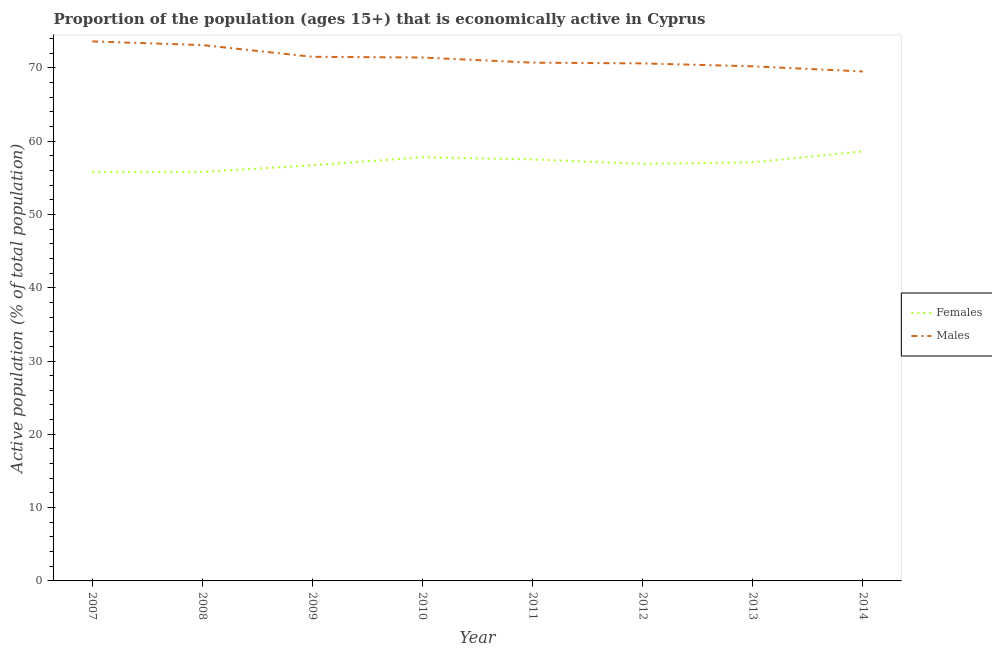How many different coloured lines are there?
Offer a very short reply. 2. Does the line corresponding to percentage of economically active male population intersect with the line corresponding to percentage of economically active female population?
Your response must be concise. No. What is the percentage of economically active female population in 2013?
Your answer should be compact. 57.1. Across all years, what is the maximum percentage of economically active male population?
Provide a succinct answer. 73.6. Across all years, what is the minimum percentage of economically active female population?
Ensure brevity in your answer.  55.8. In which year was the percentage of economically active male population minimum?
Provide a short and direct response. 2014. What is the total percentage of economically active male population in the graph?
Ensure brevity in your answer.  570.6. What is the difference between the percentage of economically active female population in 2009 and that in 2012?
Your response must be concise. -0.2. What is the difference between the percentage of economically active female population in 2013 and the percentage of economically active male population in 2014?
Offer a very short reply. -12.4. What is the average percentage of economically active female population per year?
Provide a succinct answer. 57.02. In the year 2009, what is the difference between the percentage of economically active female population and percentage of economically active male population?
Provide a short and direct response. -14.8. In how many years, is the percentage of economically active female population greater than 26 %?
Keep it short and to the point. 8. What is the ratio of the percentage of economically active female population in 2010 to that in 2014?
Keep it short and to the point. 0.99. Is the percentage of economically active male population in 2008 less than that in 2011?
Give a very brief answer. No. Is the difference between the percentage of economically active male population in 2011 and 2014 greater than the difference between the percentage of economically active female population in 2011 and 2014?
Give a very brief answer. Yes. What is the difference between the highest and the second highest percentage of economically active female population?
Your response must be concise. 0.8. What is the difference between the highest and the lowest percentage of economically active female population?
Your answer should be very brief. 2.8. In how many years, is the percentage of economically active male population greater than the average percentage of economically active male population taken over all years?
Ensure brevity in your answer.  4. Is the percentage of economically active male population strictly greater than the percentage of economically active female population over the years?
Make the answer very short. Yes. Is the percentage of economically active male population strictly less than the percentage of economically active female population over the years?
Give a very brief answer. No. Are the values on the major ticks of Y-axis written in scientific E-notation?
Offer a terse response. No. Where does the legend appear in the graph?
Ensure brevity in your answer.  Center right. What is the title of the graph?
Ensure brevity in your answer.  Proportion of the population (ages 15+) that is economically active in Cyprus. Does "Crop" appear as one of the legend labels in the graph?
Give a very brief answer. No. What is the label or title of the Y-axis?
Offer a terse response. Active population (% of total population). What is the Active population (% of total population) of Females in 2007?
Your response must be concise. 55.8. What is the Active population (% of total population) of Males in 2007?
Ensure brevity in your answer.  73.6. What is the Active population (% of total population) of Females in 2008?
Provide a short and direct response. 55.8. What is the Active population (% of total population) of Males in 2008?
Your response must be concise. 73.1. What is the Active population (% of total population) in Females in 2009?
Keep it short and to the point. 56.7. What is the Active population (% of total population) of Males in 2009?
Keep it short and to the point. 71.5. What is the Active population (% of total population) in Females in 2010?
Provide a succinct answer. 57.8. What is the Active population (% of total population) of Males in 2010?
Provide a succinct answer. 71.4. What is the Active population (% of total population) of Females in 2011?
Provide a succinct answer. 57.5. What is the Active population (% of total population) of Males in 2011?
Your response must be concise. 70.7. What is the Active population (% of total population) of Females in 2012?
Make the answer very short. 56.9. What is the Active population (% of total population) in Males in 2012?
Offer a terse response. 70.6. What is the Active population (% of total population) in Females in 2013?
Ensure brevity in your answer.  57.1. What is the Active population (% of total population) of Males in 2013?
Keep it short and to the point. 70.2. What is the Active population (% of total population) in Females in 2014?
Your response must be concise. 58.6. What is the Active population (% of total population) in Males in 2014?
Your answer should be very brief. 69.5. Across all years, what is the maximum Active population (% of total population) of Females?
Your answer should be very brief. 58.6. Across all years, what is the maximum Active population (% of total population) in Males?
Provide a short and direct response. 73.6. Across all years, what is the minimum Active population (% of total population) in Females?
Offer a very short reply. 55.8. Across all years, what is the minimum Active population (% of total population) of Males?
Provide a succinct answer. 69.5. What is the total Active population (% of total population) of Females in the graph?
Offer a very short reply. 456.2. What is the total Active population (% of total population) of Males in the graph?
Give a very brief answer. 570.6. What is the difference between the Active population (% of total population) in Females in 2007 and that in 2008?
Provide a succinct answer. 0. What is the difference between the Active population (% of total population) in Males in 2007 and that in 2010?
Your answer should be compact. 2.2. What is the difference between the Active population (% of total population) of Females in 2007 and that in 2011?
Give a very brief answer. -1.7. What is the difference between the Active population (% of total population) of Males in 2007 and that in 2013?
Give a very brief answer. 3.4. What is the difference between the Active population (% of total population) in Females in 2008 and that in 2009?
Your answer should be compact. -0.9. What is the difference between the Active population (% of total population) in Males in 2008 and that in 2009?
Your answer should be very brief. 1.6. What is the difference between the Active population (% of total population) in Females in 2008 and that in 2010?
Make the answer very short. -2. What is the difference between the Active population (% of total population) in Males in 2008 and that in 2010?
Make the answer very short. 1.7. What is the difference between the Active population (% of total population) in Females in 2008 and that in 2011?
Give a very brief answer. -1.7. What is the difference between the Active population (% of total population) of Males in 2008 and that in 2011?
Offer a very short reply. 2.4. What is the difference between the Active population (% of total population) in Males in 2008 and that in 2012?
Provide a succinct answer. 2.5. What is the difference between the Active population (% of total population) of Females in 2008 and that in 2013?
Keep it short and to the point. -1.3. What is the difference between the Active population (% of total population) in Females in 2009 and that in 2011?
Make the answer very short. -0.8. What is the difference between the Active population (% of total population) of Females in 2009 and that in 2012?
Provide a short and direct response. -0.2. What is the difference between the Active population (% of total population) in Females in 2009 and that in 2013?
Provide a succinct answer. -0.4. What is the difference between the Active population (% of total population) in Females in 2010 and that in 2011?
Ensure brevity in your answer.  0.3. What is the difference between the Active population (% of total population) of Males in 2010 and that in 2011?
Ensure brevity in your answer.  0.7. What is the difference between the Active population (% of total population) in Females in 2010 and that in 2012?
Make the answer very short. 0.9. What is the difference between the Active population (% of total population) in Females in 2010 and that in 2014?
Your answer should be very brief. -0.8. What is the difference between the Active population (% of total population) of Males in 2010 and that in 2014?
Give a very brief answer. 1.9. What is the difference between the Active population (% of total population) in Females in 2011 and that in 2013?
Offer a very short reply. 0.4. What is the difference between the Active population (% of total population) in Females in 2011 and that in 2014?
Keep it short and to the point. -1.1. What is the difference between the Active population (% of total population) of Females in 2012 and that in 2014?
Provide a succinct answer. -1.7. What is the difference between the Active population (% of total population) in Males in 2012 and that in 2014?
Provide a short and direct response. 1.1. What is the difference between the Active population (% of total population) in Males in 2013 and that in 2014?
Your answer should be very brief. 0.7. What is the difference between the Active population (% of total population) in Females in 2007 and the Active population (% of total population) in Males in 2008?
Your answer should be compact. -17.3. What is the difference between the Active population (% of total population) of Females in 2007 and the Active population (% of total population) of Males in 2009?
Keep it short and to the point. -15.7. What is the difference between the Active population (% of total population) of Females in 2007 and the Active population (% of total population) of Males in 2010?
Give a very brief answer. -15.6. What is the difference between the Active population (% of total population) of Females in 2007 and the Active population (% of total population) of Males in 2011?
Your answer should be compact. -14.9. What is the difference between the Active population (% of total population) in Females in 2007 and the Active population (% of total population) in Males in 2012?
Make the answer very short. -14.8. What is the difference between the Active population (% of total population) of Females in 2007 and the Active population (% of total population) of Males in 2013?
Offer a very short reply. -14.4. What is the difference between the Active population (% of total population) of Females in 2007 and the Active population (% of total population) of Males in 2014?
Your answer should be very brief. -13.7. What is the difference between the Active population (% of total population) of Females in 2008 and the Active population (% of total population) of Males in 2009?
Ensure brevity in your answer.  -15.7. What is the difference between the Active population (% of total population) in Females in 2008 and the Active population (% of total population) in Males in 2010?
Offer a terse response. -15.6. What is the difference between the Active population (% of total population) of Females in 2008 and the Active population (% of total population) of Males in 2011?
Make the answer very short. -14.9. What is the difference between the Active population (% of total population) of Females in 2008 and the Active population (% of total population) of Males in 2012?
Give a very brief answer. -14.8. What is the difference between the Active population (% of total population) of Females in 2008 and the Active population (% of total population) of Males in 2013?
Offer a very short reply. -14.4. What is the difference between the Active population (% of total population) in Females in 2008 and the Active population (% of total population) in Males in 2014?
Offer a very short reply. -13.7. What is the difference between the Active population (% of total population) in Females in 2009 and the Active population (% of total population) in Males in 2010?
Provide a short and direct response. -14.7. What is the difference between the Active population (% of total population) in Females in 2009 and the Active population (% of total population) in Males in 2012?
Make the answer very short. -13.9. What is the difference between the Active population (% of total population) in Females in 2009 and the Active population (% of total population) in Males in 2013?
Your answer should be compact. -13.5. What is the difference between the Active population (% of total population) in Females in 2010 and the Active population (% of total population) in Males in 2011?
Ensure brevity in your answer.  -12.9. What is the difference between the Active population (% of total population) in Females in 2010 and the Active population (% of total population) in Males in 2014?
Your answer should be compact. -11.7. What is the difference between the Active population (% of total population) of Females in 2011 and the Active population (% of total population) of Males in 2012?
Offer a very short reply. -13.1. What is the difference between the Active population (% of total population) of Females in 2011 and the Active population (% of total population) of Males in 2013?
Offer a terse response. -12.7. What is the difference between the Active population (% of total population) of Females in 2011 and the Active population (% of total population) of Males in 2014?
Give a very brief answer. -12. What is the difference between the Active population (% of total population) in Females in 2012 and the Active population (% of total population) in Males in 2013?
Your response must be concise. -13.3. What is the difference between the Active population (% of total population) of Females in 2012 and the Active population (% of total population) of Males in 2014?
Provide a succinct answer. -12.6. What is the difference between the Active population (% of total population) in Females in 2013 and the Active population (% of total population) in Males in 2014?
Provide a succinct answer. -12.4. What is the average Active population (% of total population) in Females per year?
Your response must be concise. 57.02. What is the average Active population (% of total population) in Males per year?
Offer a very short reply. 71.33. In the year 2007, what is the difference between the Active population (% of total population) in Females and Active population (% of total population) in Males?
Keep it short and to the point. -17.8. In the year 2008, what is the difference between the Active population (% of total population) of Females and Active population (% of total population) of Males?
Make the answer very short. -17.3. In the year 2009, what is the difference between the Active population (% of total population) in Females and Active population (% of total population) in Males?
Ensure brevity in your answer.  -14.8. In the year 2011, what is the difference between the Active population (% of total population) in Females and Active population (% of total population) in Males?
Your answer should be very brief. -13.2. In the year 2012, what is the difference between the Active population (% of total population) in Females and Active population (% of total population) in Males?
Your response must be concise. -13.7. In the year 2013, what is the difference between the Active population (% of total population) of Females and Active population (% of total population) of Males?
Your answer should be very brief. -13.1. What is the ratio of the Active population (% of total population) of Females in 2007 to that in 2008?
Your answer should be very brief. 1. What is the ratio of the Active population (% of total population) of Males in 2007 to that in 2008?
Ensure brevity in your answer.  1.01. What is the ratio of the Active population (% of total population) of Females in 2007 to that in 2009?
Your response must be concise. 0.98. What is the ratio of the Active population (% of total population) of Males in 2007 to that in 2009?
Provide a succinct answer. 1.03. What is the ratio of the Active population (% of total population) in Females in 2007 to that in 2010?
Keep it short and to the point. 0.97. What is the ratio of the Active population (% of total population) in Males in 2007 to that in 2010?
Your answer should be compact. 1.03. What is the ratio of the Active population (% of total population) in Females in 2007 to that in 2011?
Offer a very short reply. 0.97. What is the ratio of the Active population (% of total population) of Males in 2007 to that in 2011?
Your answer should be very brief. 1.04. What is the ratio of the Active population (% of total population) of Females in 2007 to that in 2012?
Your answer should be compact. 0.98. What is the ratio of the Active population (% of total population) in Males in 2007 to that in 2012?
Make the answer very short. 1.04. What is the ratio of the Active population (% of total population) of Females in 2007 to that in 2013?
Offer a terse response. 0.98. What is the ratio of the Active population (% of total population) of Males in 2007 to that in 2013?
Your response must be concise. 1.05. What is the ratio of the Active population (% of total population) in Females in 2007 to that in 2014?
Offer a terse response. 0.95. What is the ratio of the Active population (% of total population) in Males in 2007 to that in 2014?
Ensure brevity in your answer.  1.06. What is the ratio of the Active population (% of total population) in Females in 2008 to that in 2009?
Provide a succinct answer. 0.98. What is the ratio of the Active population (% of total population) of Males in 2008 to that in 2009?
Your answer should be very brief. 1.02. What is the ratio of the Active population (% of total population) in Females in 2008 to that in 2010?
Make the answer very short. 0.97. What is the ratio of the Active population (% of total population) of Males in 2008 to that in 2010?
Provide a short and direct response. 1.02. What is the ratio of the Active population (% of total population) in Females in 2008 to that in 2011?
Ensure brevity in your answer.  0.97. What is the ratio of the Active population (% of total population) of Males in 2008 to that in 2011?
Keep it short and to the point. 1.03. What is the ratio of the Active population (% of total population) in Females in 2008 to that in 2012?
Keep it short and to the point. 0.98. What is the ratio of the Active population (% of total population) of Males in 2008 to that in 2012?
Your answer should be compact. 1.04. What is the ratio of the Active population (% of total population) of Females in 2008 to that in 2013?
Your answer should be compact. 0.98. What is the ratio of the Active population (% of total population) in Males in 2008 to that in 2013?
Your answer should be very brief. 1.04. What is the ratio of the Active population (% of total population) of Females in 2008 to that in 2014?
Give a very brief answer. 0.95. What is the ratio of the Active population (% of total population) in Males in 2008 to that in 2014?
Your response must be concise. 1.05. What is the ratio of the Active population (% of total population) in Males in 2009 to that in 2010?
Provide a succinct answer. 1. What is the ratio of the Active population (% of total population) of Females in 2009 to that in 2011?
Your response must be concise. 0.99. What is the ratio of the Active population (% of total population) of Males in 2009 to that in 2011?
Make the answer very short. 1.01. What is the ratio of the Active population (% of total population) in Males in 2009 to that in 2012?
Your response must be concise. 1.01. What is the ratio of the Active population (% of total population) of Males in 2009 to that in 2013?
Your answer should be compact. 1.02. What is the ratio of the Active population (% of total population) of Females in 2009 to that in 2014?
Your response must be concise. 0.97. What is the ratio of the Active population (% of total population) of Males in 2009 to that in 2014?
Make the answer very short. 1.03. What is the ratio of the Active population (% of total population) in Males in 2010 to that in 2011?
Keep it short and to the point. 1.01. What is the ratio of the Active population (% of total population) in Females in 2010 to that in 2012?
Provide a succinct answer. 1.02. What is the ratio of the Active population (% of total population) in Males in 2010 to that in 2012?
Ensure brevity in your answer.  1.01. What is the ratio of the Active population (% of total population) of Females in 2010 to that in 2013?
Your response must be concise. 1.01. What is the ratio of the Active population (% of total population) of Males in 2010 to that in 2013?
Your answer should be compact. 1.02. What is the ratio of the Active population (% of total population) in Females in 2010 to that in 2014?
Provide a succinct answer. 0.99. What is the ratio of the Active population (% of total population) in Males in 2010 to that in 2014?
Your answer should be very brief. 1.03. What is the ratio of the Active population (% of total population) of Females in 2011 to that in 2012?
Give a very brief answer. 1.01. What is the ratio of the Active population (% of total population) in Males in 2011 to that in 2012?
Your answer should be very brief. 1. What is the ratio of the Active population (% of total population) of Males in 2011 to that in 2013?
Offer a terse response. 1.01. What is the ratio of the Active population (% of total population) of Females in 2011 to that in 2014?
Give a very brief answer. 0.98. What is the ratio of the Active population (% of total population) of Males in 2011 to that in 2014?
Provide a short and direct response. 1.02. What is the ratio of the Active population (% of total population) of Females in 2012 to that in 2014?
Your response must be concise. 0.97. What is the ratio of the Active population (% of total population) in Males in 2012 to that in 2014?
Ensure brevity in your answer.  1.02. What is the ratio of the Active population (% of total population) in Females in 2013 to that in 2014?
Keep it short and to the point. 0.97. What is the ratio of the Active population (% of total population) of Males in 2013 to that in 2014?
Provide a succinct answer. 1.01. What is the difference between the highest and the second highest Active population (% of total population) in Males?
Give a very brief answer. 0.5. What is the difference between the highest and the lowest Active population (% of total population) of Females?
Offer a terse response. 2.8. What is the difference between the highest and the lowest Active population (% of total population) in Males?
Offer a terse response. 4.1. 